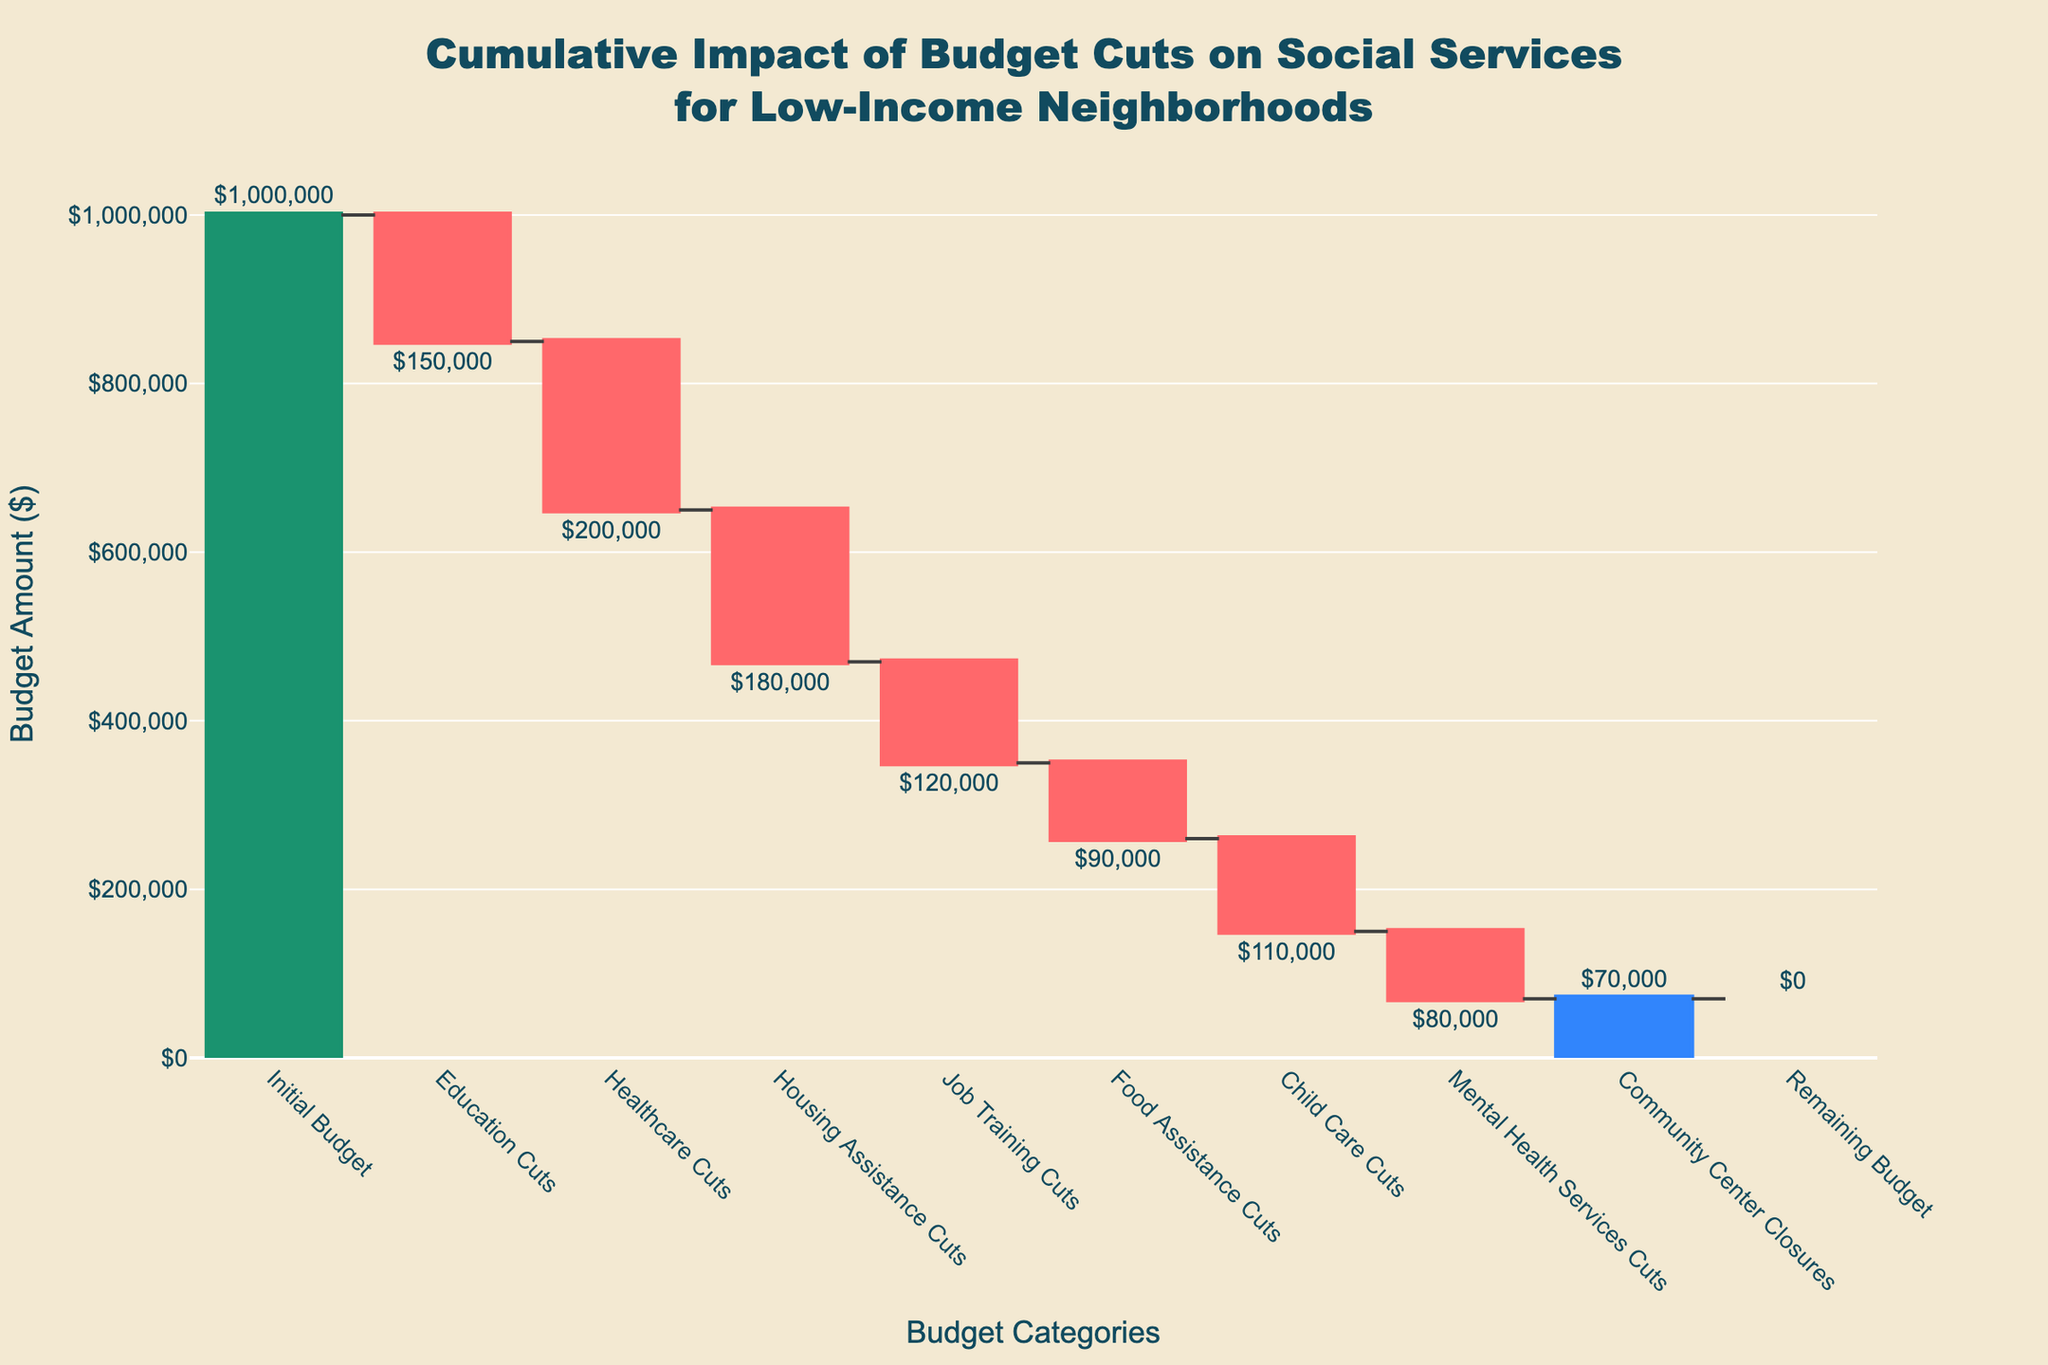What is the title of the figure? The title is located at the top center of the chart. It provides a summary of the chart content, which is "Cumulative Impact of Budget Cuts on Social Services for Low-Income Neighborhoods".
Answer: "Cumulative Impact of Budget Cuts on Social Services for Low-Income Neighborhoods" What does the y-axis represent? The y-axis label indicates what is being measured, which is the budget amount in dollars.
Answer: Budget Amount ($) What is the effect of Healthcare Cuts on the budget? By examining the length of the bar labeled "Healthcare Cuts" and its direction, you can see it cuts $200,000 from the budget.
Answer: Reduces budget by $200,000 How does the budget after Child Care Cuts compare to the initial budget? After the initial $1,000,000 budget indicated, subsequent cuts are shown. The budget after Child Care Cuts can be inferred by adding the absolute values of all cuts up to Child Care from Initial Budget and comparing. Initial Budget ($1,000,000) - (Education: $150,000 + Healthcare: $200,000 + Housing: $180,000 + Job Training: $120,000 + Food: $90,000 + Child Care: $110,000) = $1,000,000 - $850,000 = $150,000 remaining, hence, $150,000 is much less.
Answer: Much less What is the combined effect of Education Cuts and Housing Assistance Cuts on the budget? Sum the negative contributions of "Education Cuts" and "Housing Assistance Cuts". Education Cuts: -$150,000, Housing Assistance Cuts: -$180,000. Their combined effect is -$150,000 - $180,000 = -$330,000.
Answer: Reduces budget by $330,000 Which category has the smallest budget cut? Look for the bar with the smallest negative value. "Community Center Closures" has the smallest budget cut registering a $70,000 reduction.
Answer: Community Center Closures How much budget is left after all cuts? The remaining budget is mentioned explicitly at the end of the chart. The value is indicated as 0 dollars as shown by the last total bar.
Answer: $0 Which category's cuts come immediately after Healthcare Cuts and what is its value? Following the Healthcare Cuts bar, the next bar is labeled "Housing Assistance Cuts" with a value of -$180,000.
Answer: Housing Assistance Cuts, -$180,000 What is the percentage reduction in budget due to Mental Health Services Cuts relative to the initial budget? Calculate the percentage using the formula (value of Mental Health Services Cuts/Initial Budget) * 100. (-80,000/1,000,000) * 100 = 8%.
Answer: 8% In total, how much is cut from the budget by all categories before Remaining Budget? Sum all the individual cuts: -$150,000 (Education) + -$200,000 (Healthcare) + -$180,000 (Housing) + -$120,000 (Job Training) + -$90,000 (Food Assistance) + -$110,000 (Child Care) + -$80,000 (Mental Health) + -$70,000 (Community Centers) = -$1,000,000.
Answer: $1,000,000 